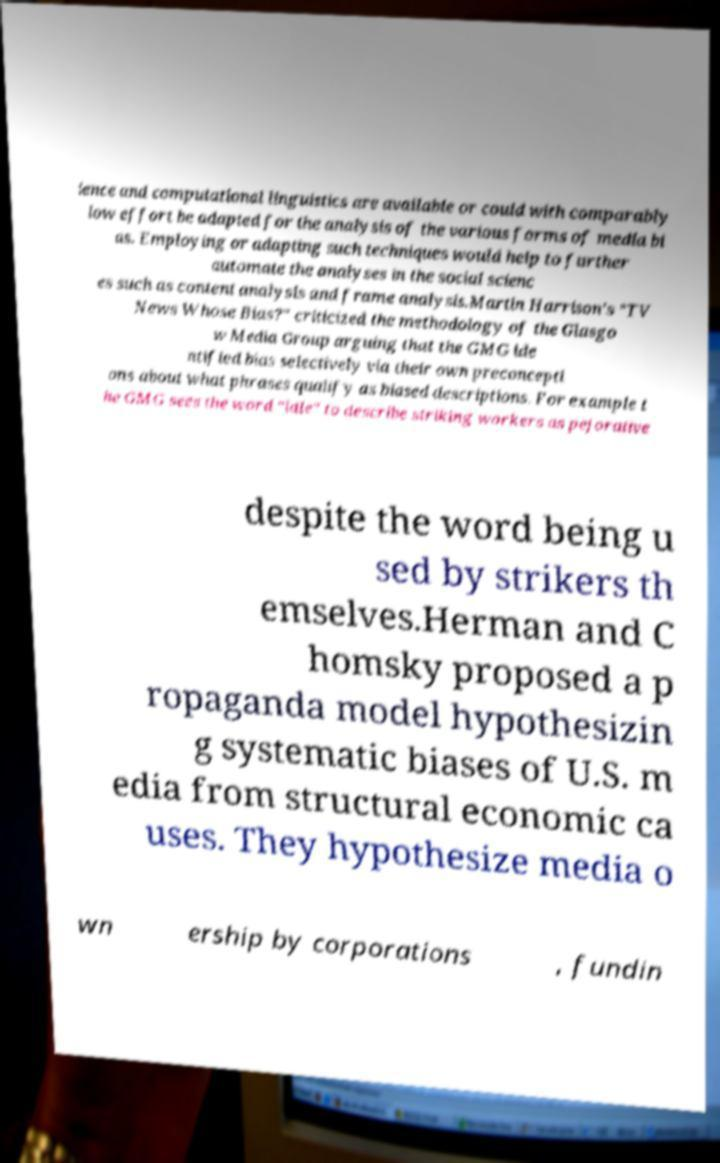What messages or text are displayed in this image? I need them in a readable, typed format. ience and computational linguistics are available or could with comparably low effort be adapted for the analysis of the various forms of media bi as. Employing or adapting such techniques would help to further automate the analyses in the social scienc es such as content analysis and frame analysis.Martin Harrison's "TV News Whose Bias?" criticized the methodology of the Glasgo w Media Group arguing that the GMG ide ntified bias selectively via their own preconcepti ons about what phrases qualify as biased descriptions. For example t he GMG sees the word "idle" to describe striking workers as pejorative despite the word being u sed by strikers th emselves.Herman and C homsky proposed a p ropaganda model hypothesizin g systematic biases of U.S. m edia from structural economic ca uses. They hypothesize media o wn ership by corporations , fundin 